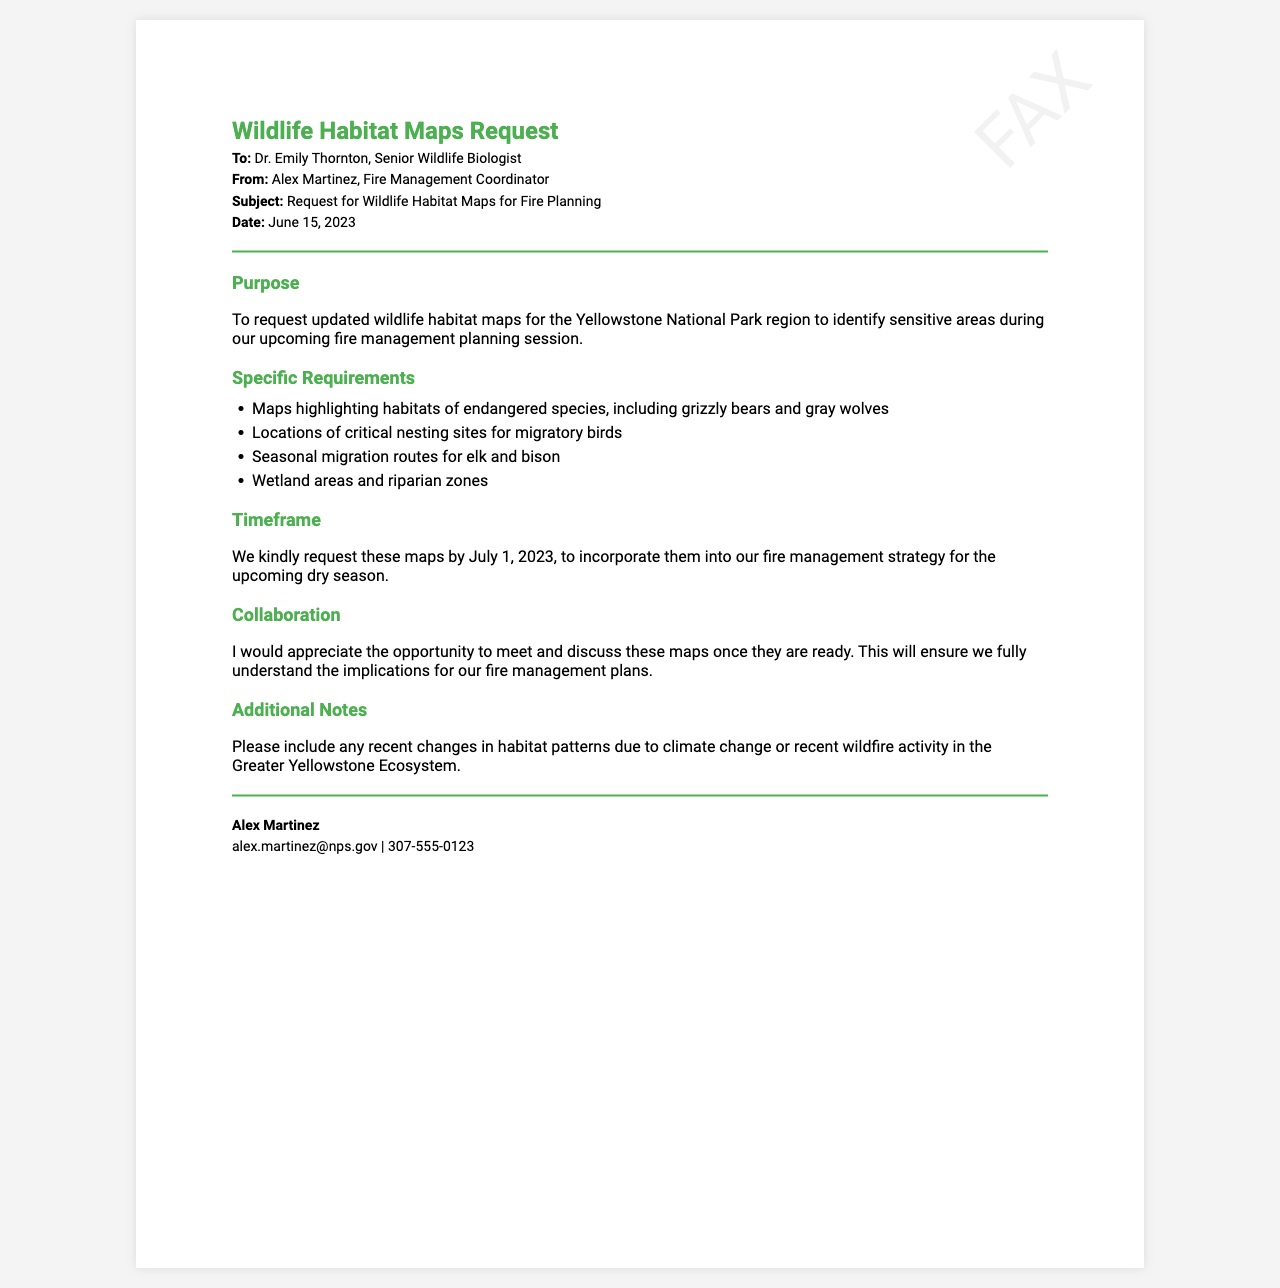what is the date of the fax? The date mentioned in the document is for the request sent, which is June 15, 2023.
Answer: June 15, 2023 who is the recipient of the fax? The fax is addressed to Dr. Emily Thornton, who is the Senior Wildlife Biologist.
Answer: Dr. Emily Thornton what is the subject of the fax? The subject clearly indicates that the fax is about requesting wildlife habitat maps for fire planning.
Answer: Request for Wildlife Habitat Maps for Fire Planning what is the deadline for the maps? The document specifies that the maps are requested by a certain date, which is July 1, 2023.
Answer: July 1, 2023 which animal species are mentioned as endangered in the request? The fax highlights the habitats of endangered species, specifically the grizzly bears and gray wolves.
Answer: grizzly bears and gray wolves what type of areas does the fax request information about besides endangered species? Additional areas requested in the document include critical nesting sites for migratory birds, seasonal migration routes, and wetland areas.
Answer: critical nesting sites for migratory birds why does the sender want to discuss the maps once they are ready? The sender expresses a desire to ensure that they fully understand the implications of the maps for their fire management plans.
Answer: to fully understand the implications what additional information is requested to be included with the maps? The sender has asked for recent changes in habitat patterns due to external factors like climate change or wildfire activity to be included.
Answer: recent changes in habitat patterns due to climate change or recent wildfire activity 